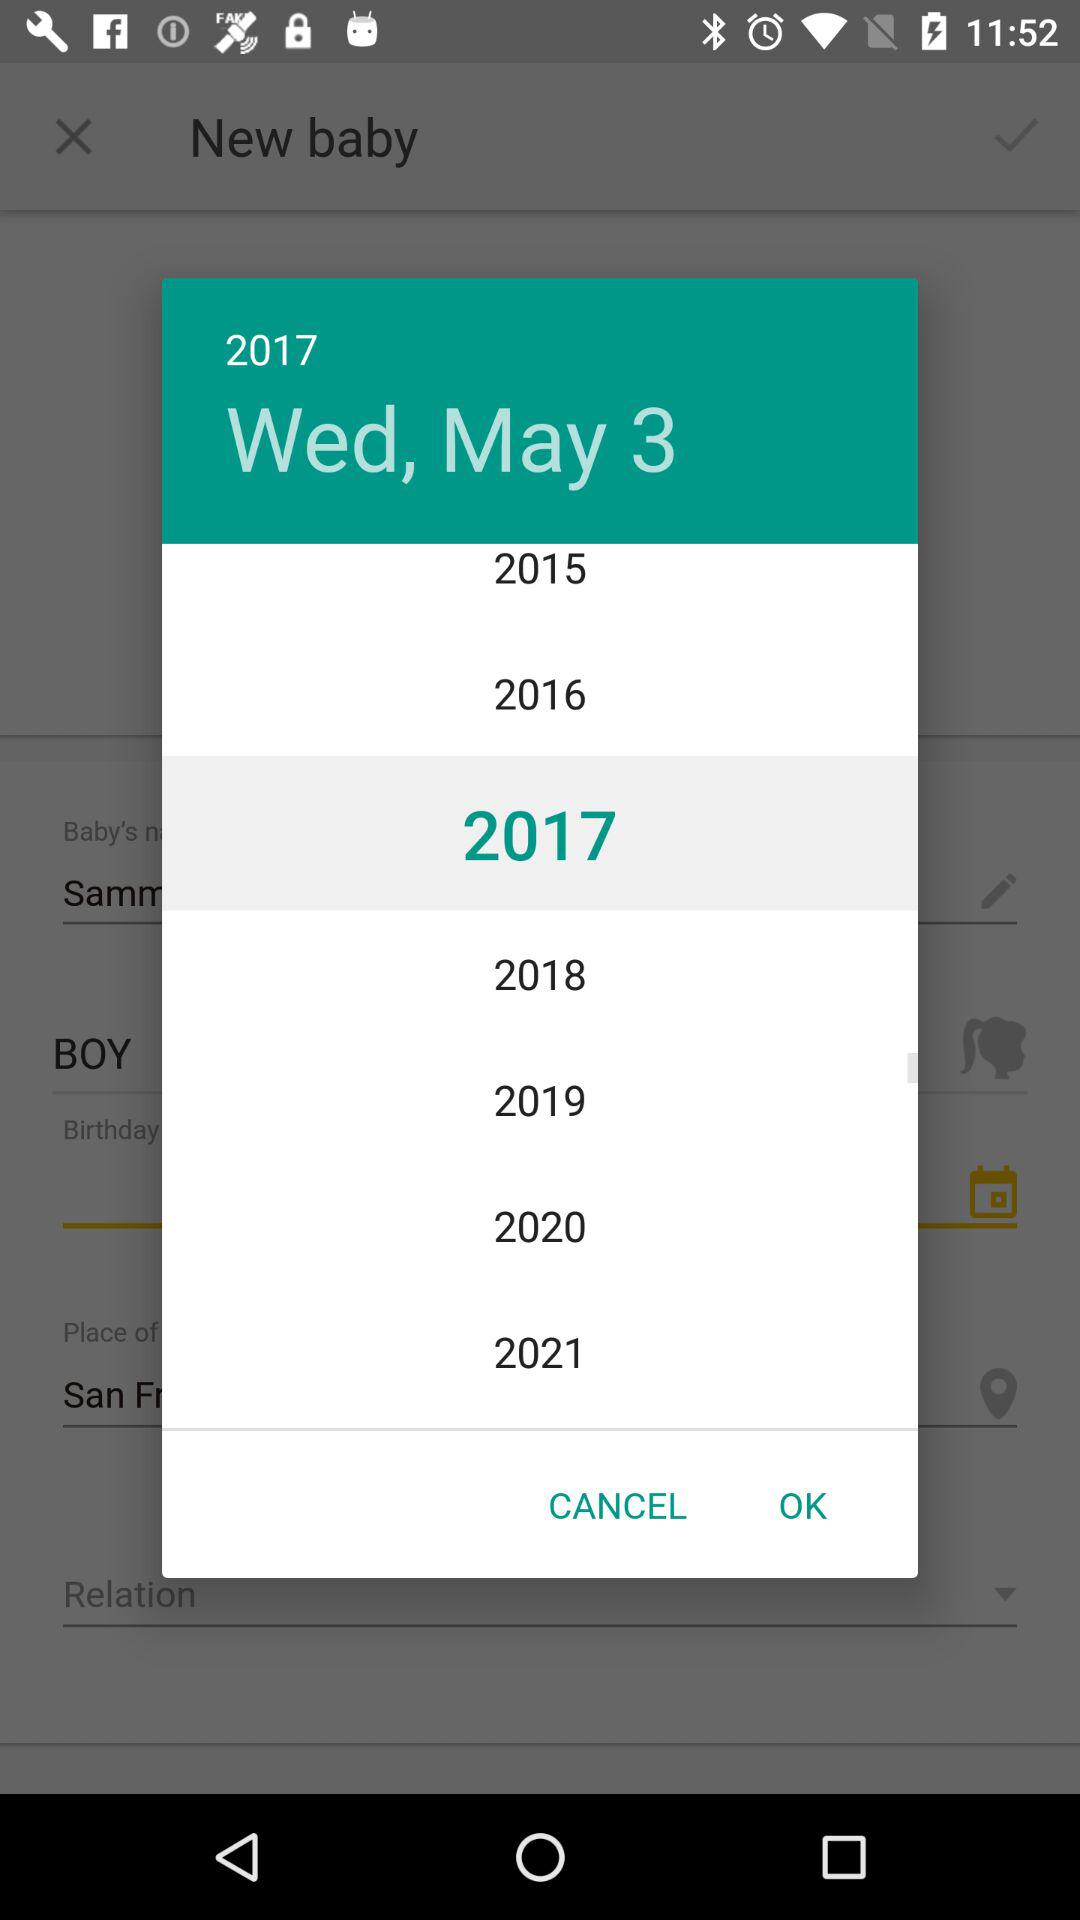Which day is on March 3rd, 2017?
When the provided information is insufficient, respond with <no answer>. <no answer> 